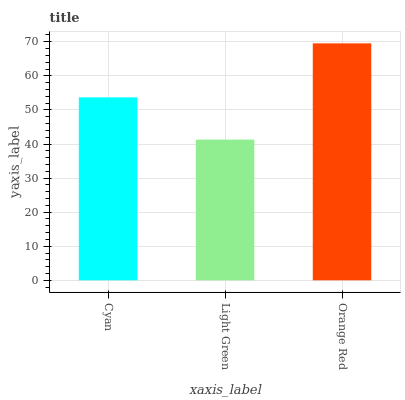Is Light Green the minimum?
Answer yes or no. Yes. Is Orange Red the maximum?
Answer yes or no. Yes. Is Orange Red the minimum?
Answer yes or no. No. Is Light Green the maximum?
Answer yes or no. No. Is Orange Red greater than Light Green?
Answer yes or no. Yes. Is Light Green less than Orange Red?
Answer yes or no. Yes. Is Light Green greater than Orange Red?
Answer yes or no. No. Is Orange Red less than Light Green?
Answer yes or no. No. Is Cyan the high median?
Answer yes or no. Yes. Is Cyan the low median?
Answer yes or no. Yes. Is Light Green the high median?
Answer yes or no. No. Is Orange Red the low median?
Answer yes or no. No. 